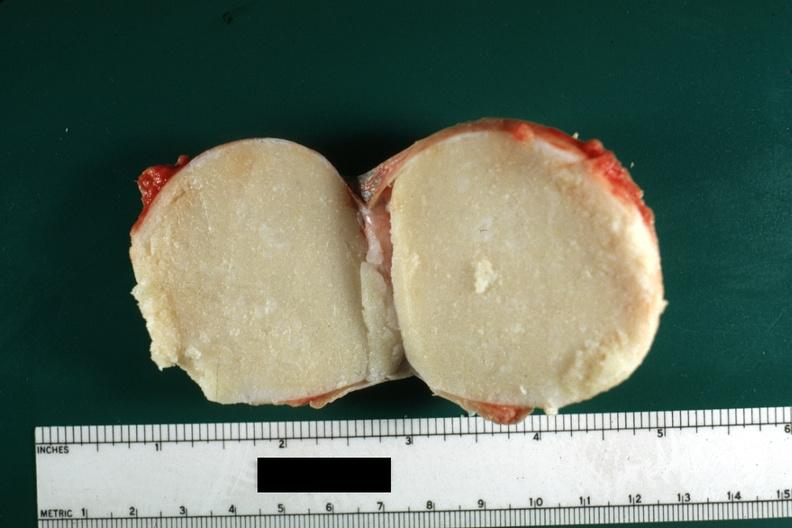s sebaceous cyst present?
Answer the question using a single word or phrase. Yes 